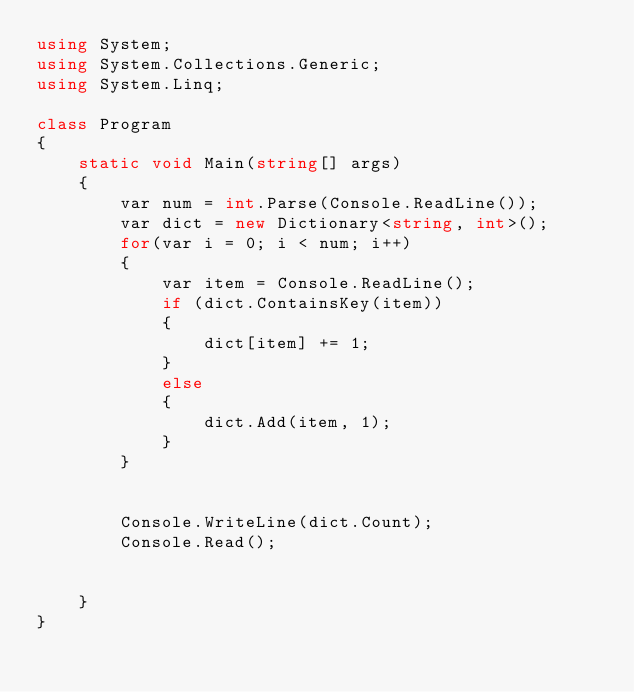Convert code to text. <code><loc_0><loc_0><loc_500><loc_500><_C#_>using System;
using System.Collections.Generic;
using System.Linq;

class Program
{
    static void Main(string[] args)
    {
        var num = int.Parse(Console.ReadLine());
        var dict = new Dictionary<string, int>();
        for(var i = 0; i < num; i++)
        {
            var item = Console.ReadLine();
            if (dict.ContainsKey(item))
            {
                dict[item] += 1;
            }
            else
            {
                dict.Add(item, 1);
            }
        }


        Console.WriteLine(dict.Count);
        Console.Read();


    }
}
</code> 